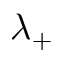<formula> <loc_0><loc_0><loc_500><loc_500>\lambda _ { + }</formula> 